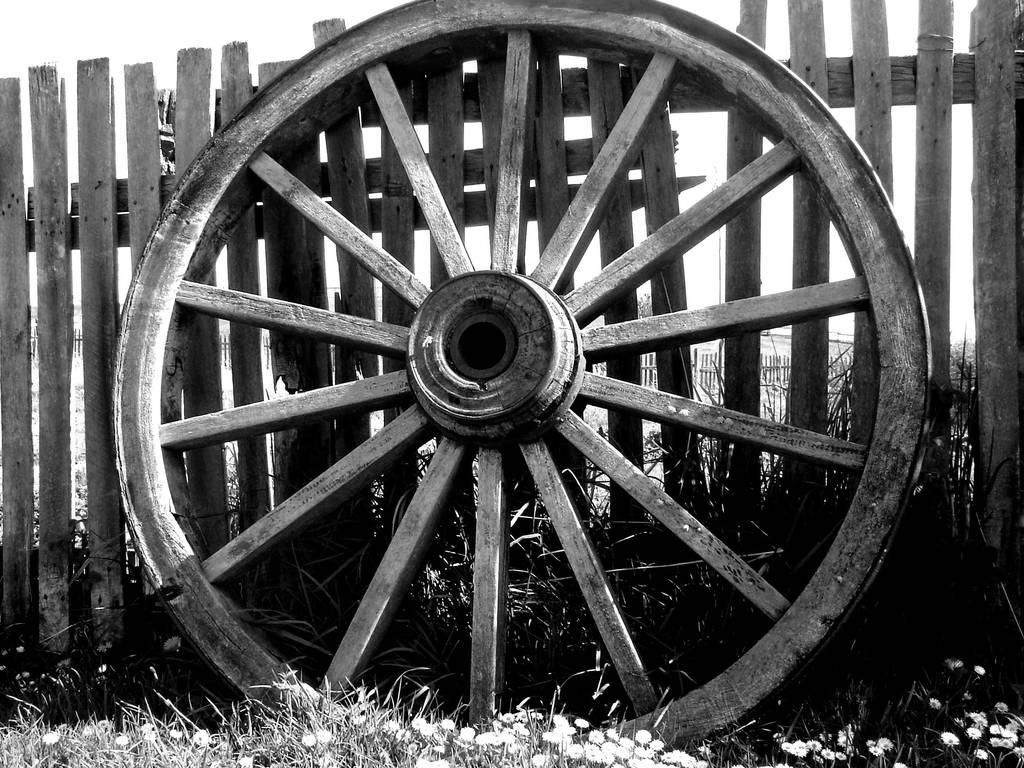What is the main object in the image? There is a wheel in the image. What type of material is used for the fencing behind the wheel? The wooden fencing is behind the wheel in the image. What is the surface made of in the image? There is grass on the surface in the image. What advice is the wheel giving to the geese in the image? There are no geese present in the image, and the wheel is an inanimate object, so it cannot give advice. 